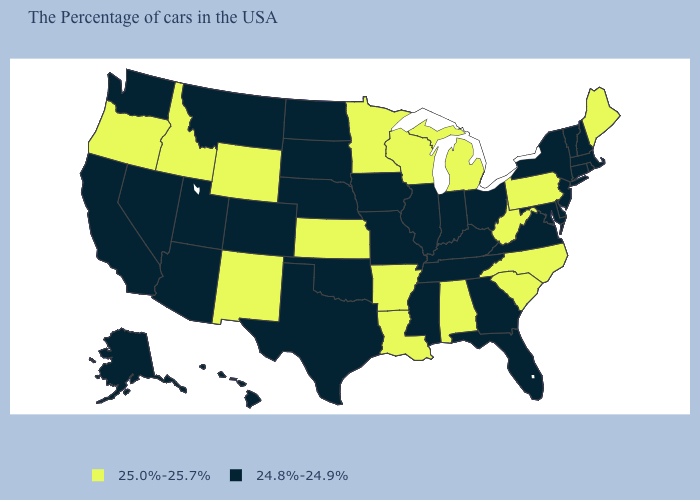How many symbols are there in the legend?
Give a very brief answer. 2. Name the states that have a value in the range 24.8%-24.9%?
Write a very short answer. Massachusetts, Rhode Island, New Hampshire, Vermont, Connecticut, New York, New Jersey, Delaware, Maryland, Virginia, Ohio, Florida, Georgia, Kentucky, Indiana, Tennessee, Illinois, Mississippi, Missouri, Iowa, Nebraska, Oklahoma, Texas, South Dakota, North Dakota, Colorado, Utah, Montana, Arizona, Nevada, California, Washington, Alaska, Hawaii. How many symbols are there in the legend?
Give a very brief answer. 2. What is the value of Nevada?
Be succinct. 24.8%-24.9%. Which states have the highest value in the USA?
Give a very brief answer. Maine, Pennsylvania, North Carolina, South Carolina, West Virginia, Michigan, Alabama, Wisconsin, Louisiana, Arkansas, Minnesota, Kansas, Wyoming, New Mexico, Idaho, Oregon. Name the states that have a value in the range 25.0%-25.7%?
Quick response, please. Maine, Pennsylvania, North Carolina, South Carolina, West Virginia, Michigan, Alabama, Wisconsin, Louisiana, Arkansas, Minnesota, Kansas, Wyoming, New Mexico, Idaho, Oregon. Name the states that have a value in the range 24.8%-24.9%?
Be succinct. Massachusetts, Rhode Island, New Hampshire, Vermont, Connecticut, New York, New Jersey, Delaware, Maryland, Virginia, Ohio, Florida, Georgia, Kentucky, Indiana, Tennessee, Illinois, Mississippi, Missouri, Iowa, Nebraska, Oklahoma, Texas, South Dakota, North Dakota, Colorado, Utah, Montana, Arizona, Nevada, California, Washington, Alaska, Hawaii. What is the value of Rhode Island?
Give a very brief answer. 24.8%-24.9%. Name the states that have a value in the range 25.0%-25.7%?
Keep it brief. Maine, Pennsylvania, North Carolina, South Carolina, West Virginia, Michigan, Alabama, Wisconsin, Louisiana, Arkansas, Minnesota, Kansas, Wyoming, New Mexico, Idaho, Oregon. What is the value of Illinois?
Answer briefly. 24.8%-24.9%. What is the value of Nebraska?
Be succinct. 24.8%-24.9%. What is the highest value in the USA?
Concise answer only. 25.0%-25.7%. Does the first symbol in the legend represent the smallest category?
Quick response, please. No. 